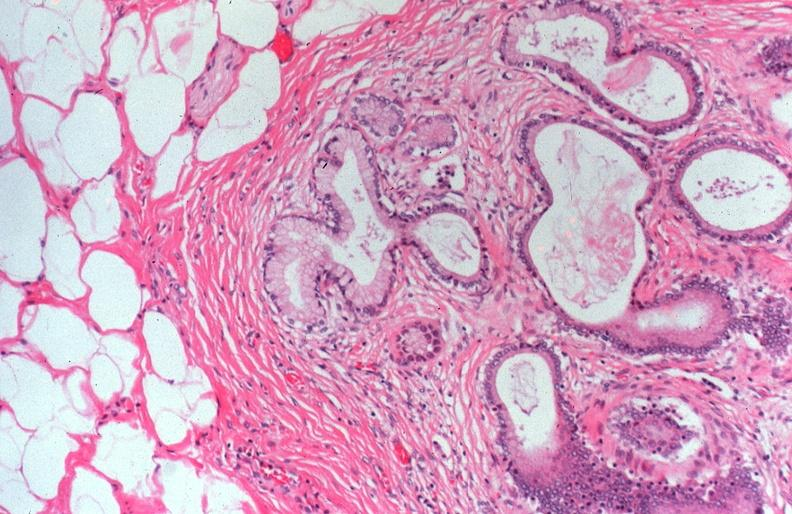does intrauterine contraceptive device show cystic fibrosis?
Answer the question using a single word or phrase. No 